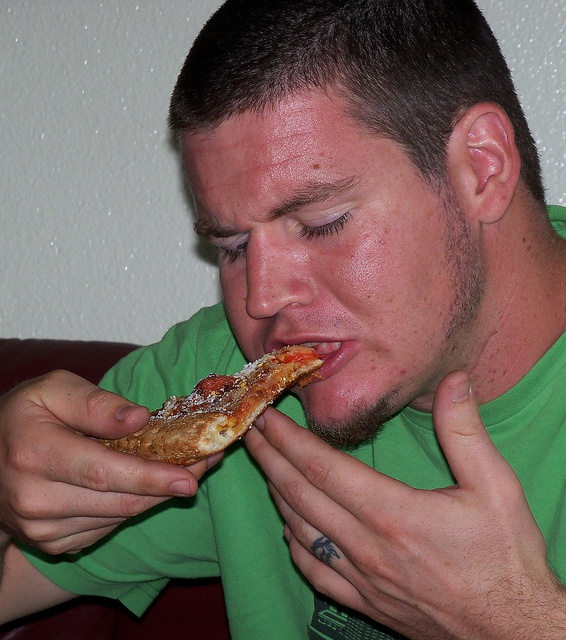Describe the objects in this image and their specific colors. I can see people in brown, gray, black, and maroon tones and pizza in gray, maroon, and brown tones in this image. 